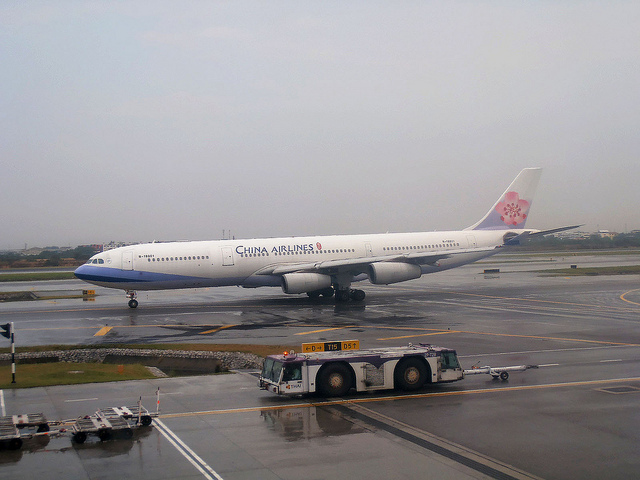Identify the text contained in this image. CHINA AIRLINES T15 